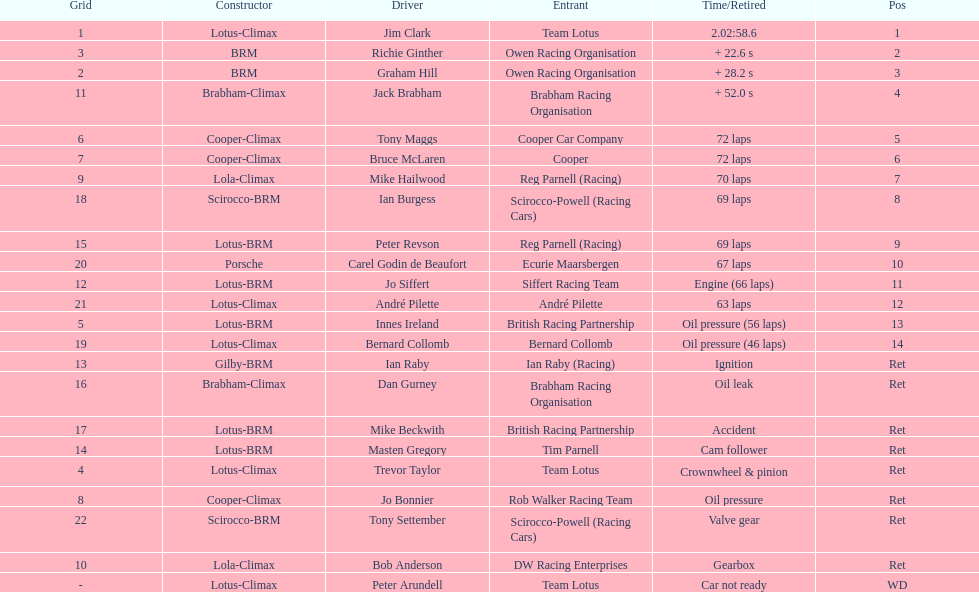How many different drivers are listed? 23. 